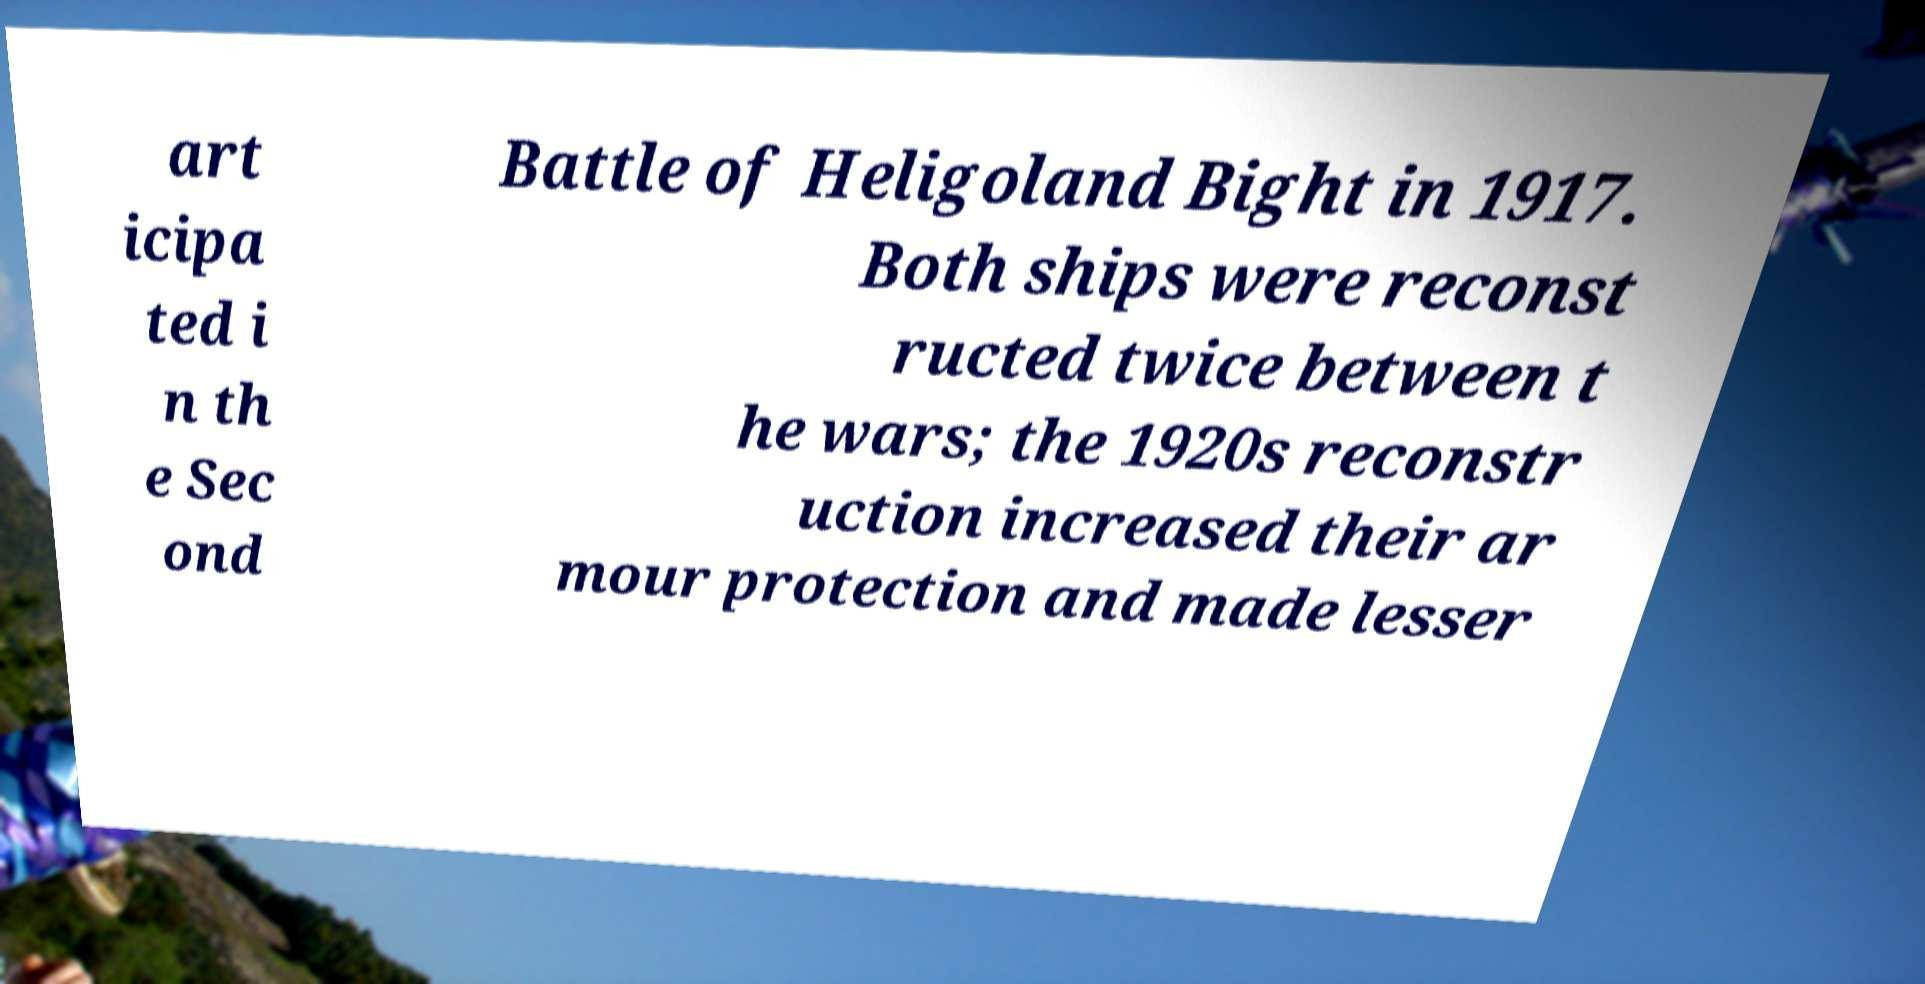Could you assist in decoding the text presented in this image and type it out clearly? art icipa ted i n th e Sec ond Battle of Heligoland Bight in 1917. Both ships were reconst ructed twice between t he wars; the 1920s reconstr uction increased their ar mour protection and made lesser 